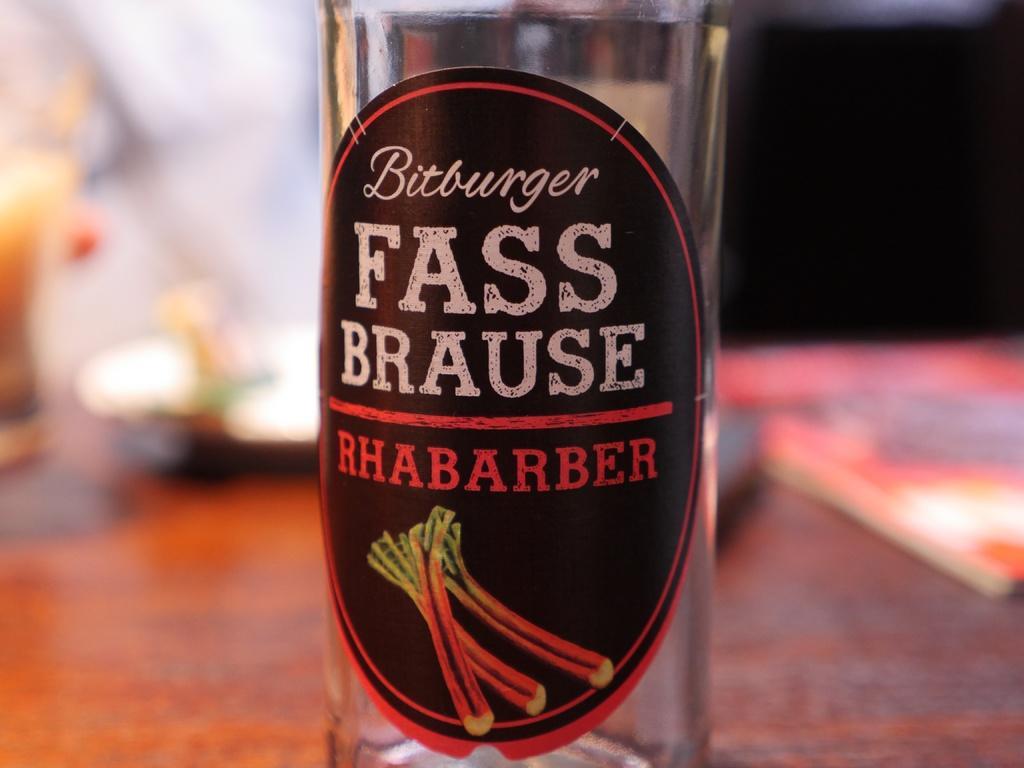In one or two sentences, can you explain what this image depicts? there is a table and on the table there are so many thing are present like bottle,plate and wine glass. 